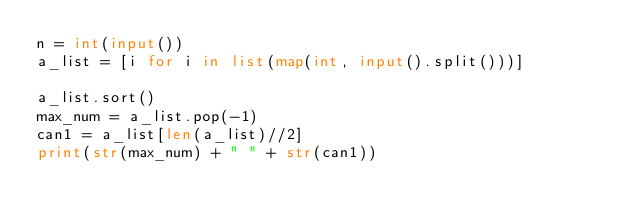Convert code to text. <code><loc_0><loc_0><loc_500><loc_500><_Python_>n = int(input())
a_list = [i for i in list(map(int, input().split()))]

a_list.sort()
max_num = a_list.pop(-1)
can1 = a_list[len(a_list)//2]
print(str(max_num) + " " + str(can1))</code> 